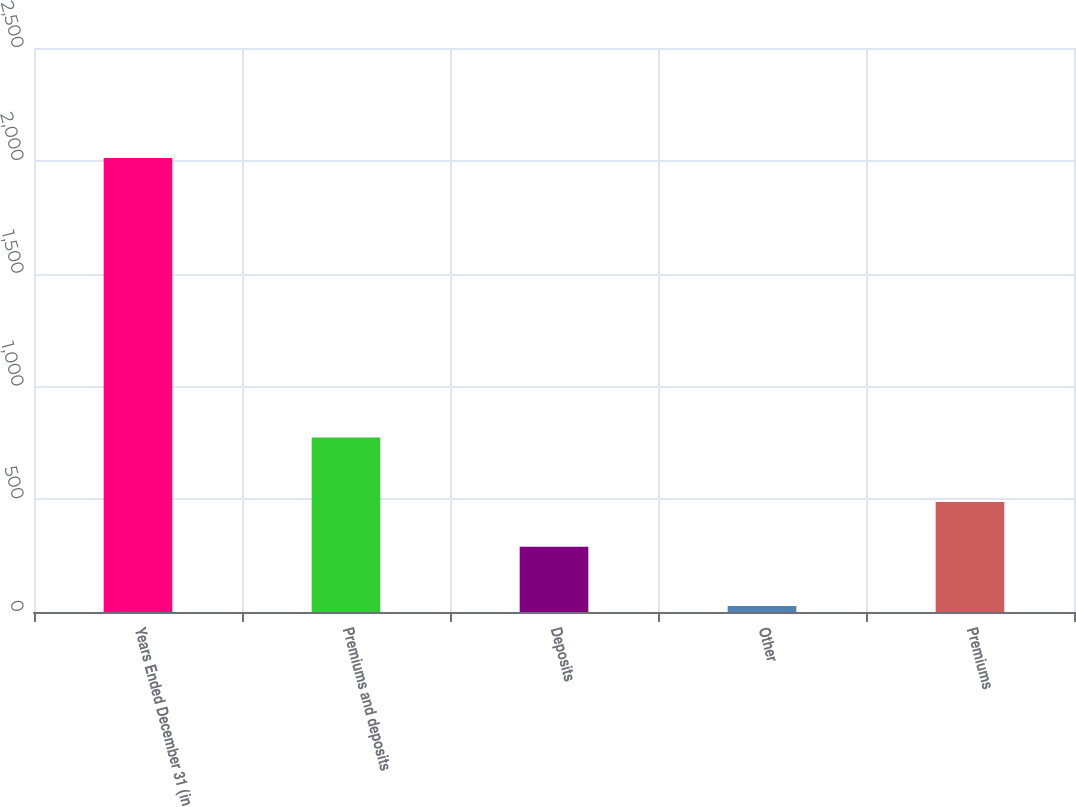<chart> <loc_0><loc_0><loc_500><loc_500><bar_chart><fcel>Years Ended December 31 (in<fcel>Premiums and deposits<fcel>Deposits<fcel>Other<fcel>Premiums<nl><fcel>2012<fcel>774<fcel>289<fcel>27<fcel>487.5<nl></chart> 